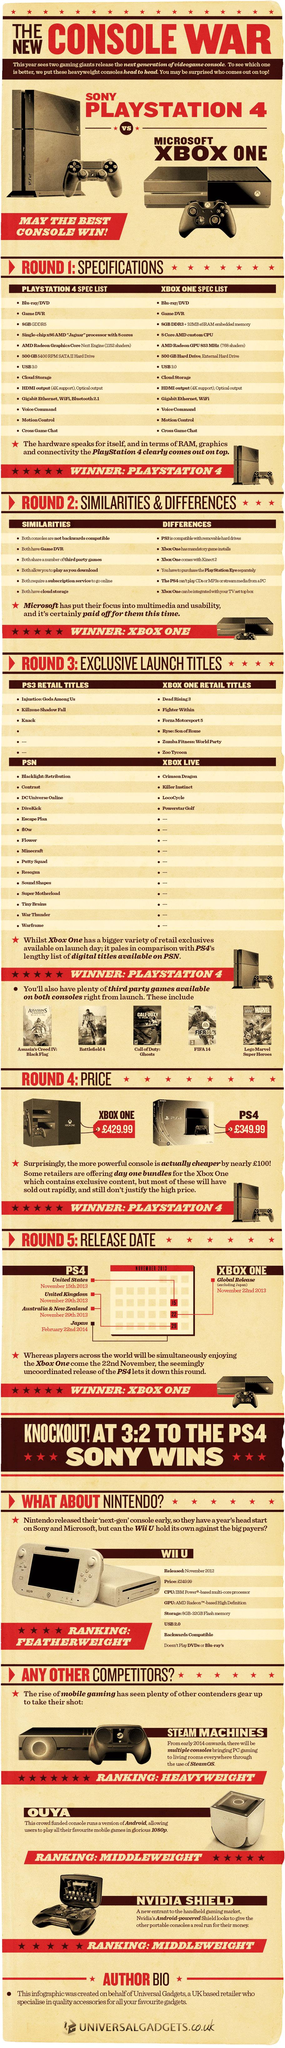Identify some key points in this picture. The XBOX ONE is a home video game console that has been developed by Microsoft. The PlayStation 4 (PS4) was first launched in the United States. The PlayStation 4 was launched in Japan on February 22nd, 2014. SteamOS is the primary operating system used for the Steam Machine gaming platform. The Nintendo Wii U is a home video game console that was developed by Nintendo. 